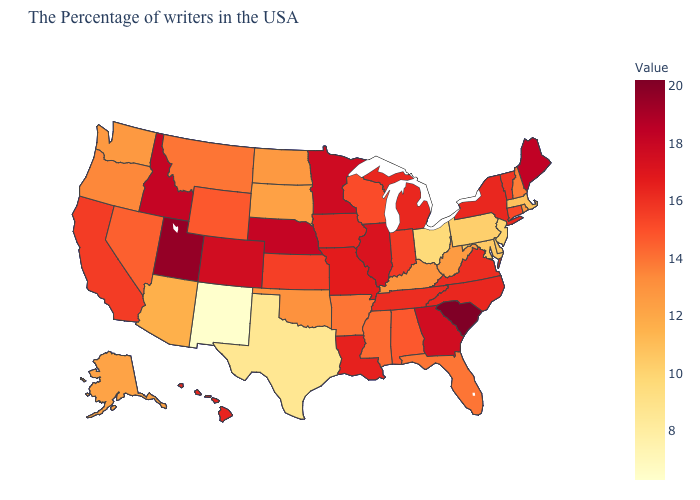Among the states that border Virginia , does Tennessee have the lowest value?
Give a very brief answer. No. Among the states that border North Dakota , does Minnesota have the highest value?
Write a very short answer. Yes. Among the states that border Mississippi , which have the highest value?
Answer briefly. Louisiana. Which states have the lowest value in the USA?
Write a very short answer. New Mexico. Does New Mexico have the lowest value in the West?
Concise answer only. Yes. Which states have the lowest value in the USA?
Keep it brief. New Mexico. Does Texas have the lowest value in the South?
Keep it brief. Yes. 